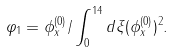Convert formula to latex. <formula><loc_0><loc_0><loc_500><loc_500>\varphi _ { 1 } = \phi _ { x } ^ { ( 0 ) } / \int _ { 0 } ^ { 1 4 } d \xi ( \phi _ { x } ^ { ( 0 ) } ) ^ { 2 } .</formula> 